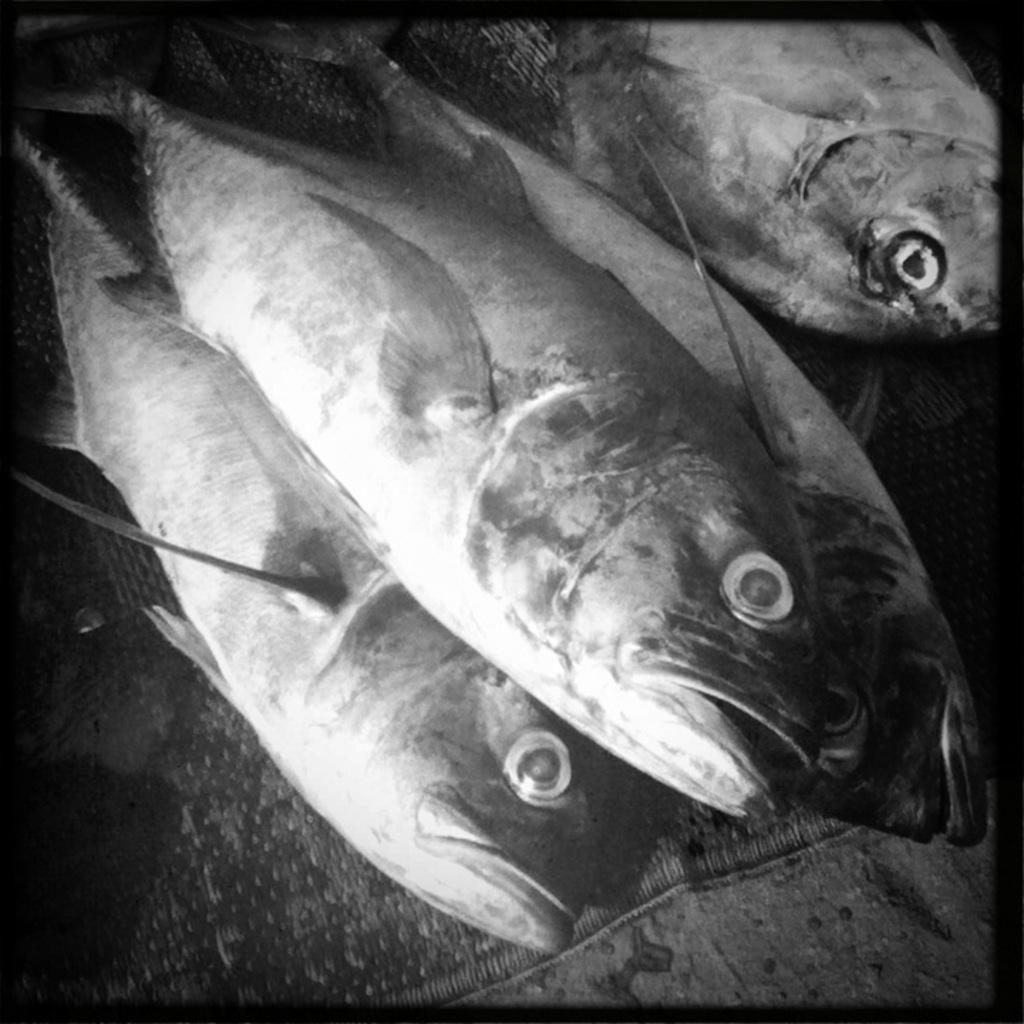What is the color scheme of the image? The image is black and white. What can be seen on the mat in the image? There are fishes on a mat in the image. How many pets are visible on the island in the image? There is no island or pets present in the image; it features a black and white image of fishes on a mat. 